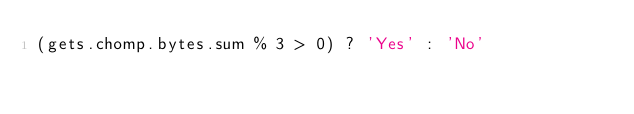<code> <loc_0><loc_0><loc_500><loc_500><_Ruby_>(gets.chomp.bytes.sum % 3 > 0) ? 'Yes' : 'No'</code> 